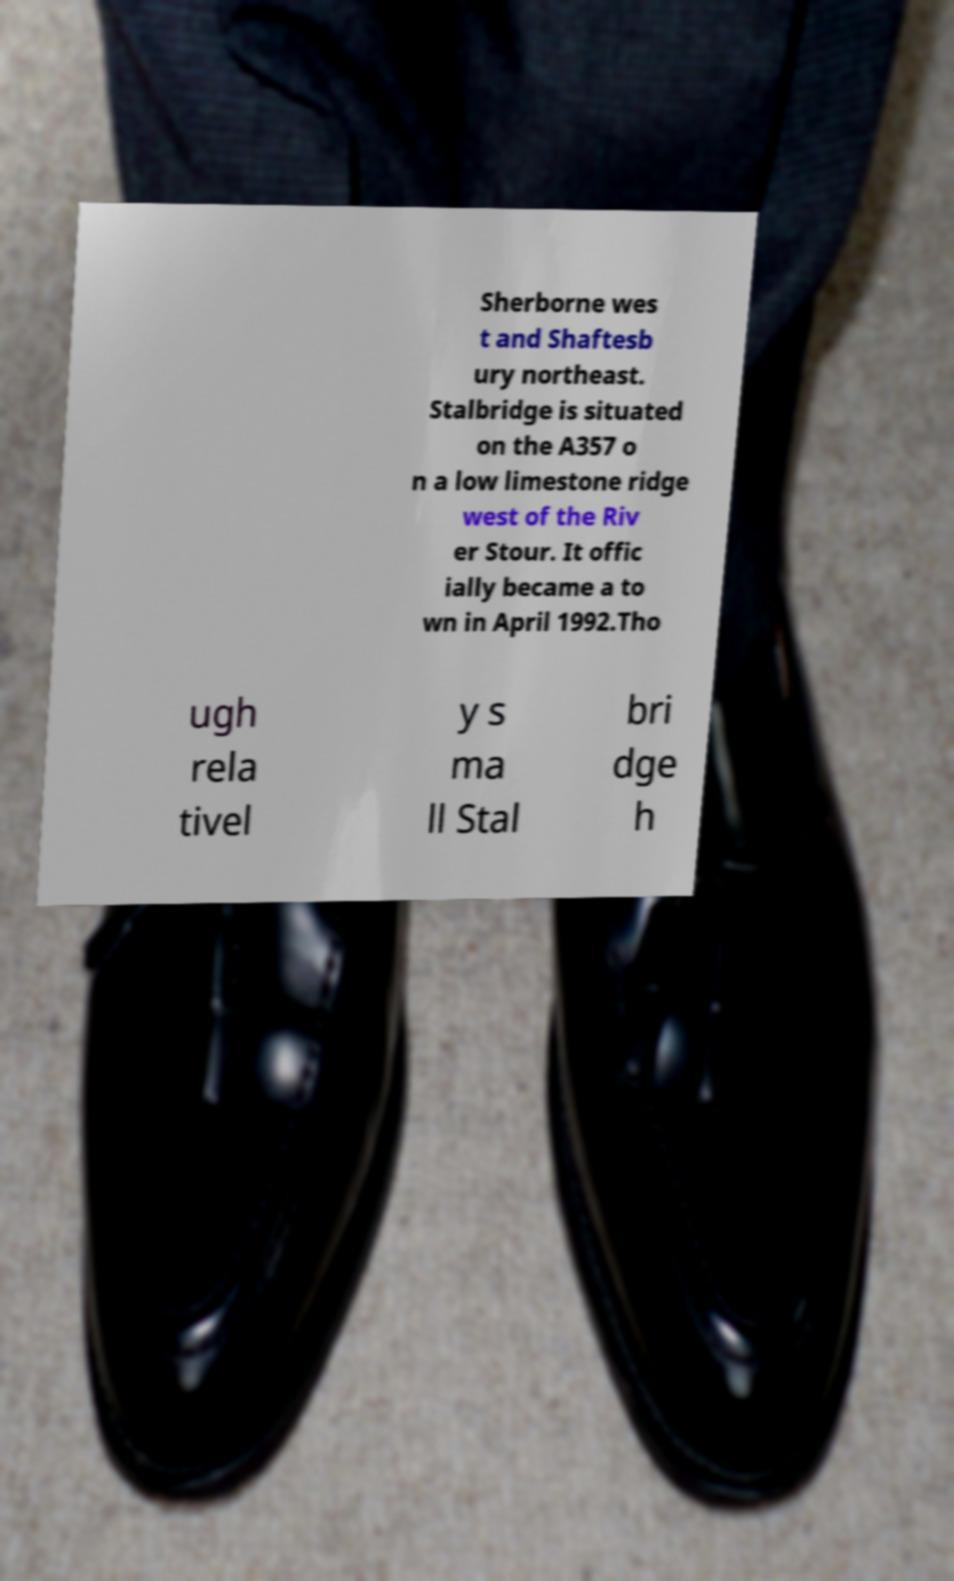What messages or text are displayed in this image? I need them in a readable, typed format. Sherborne wes t and Shaftesb ury northeast. Stalbridge is situated on the A357 o n a low limestone ridge west of the Riv er Stour. It offic ially became a to wn in April 1992.Tho ugh rela tivel y s ma ll Stal bri dge h 